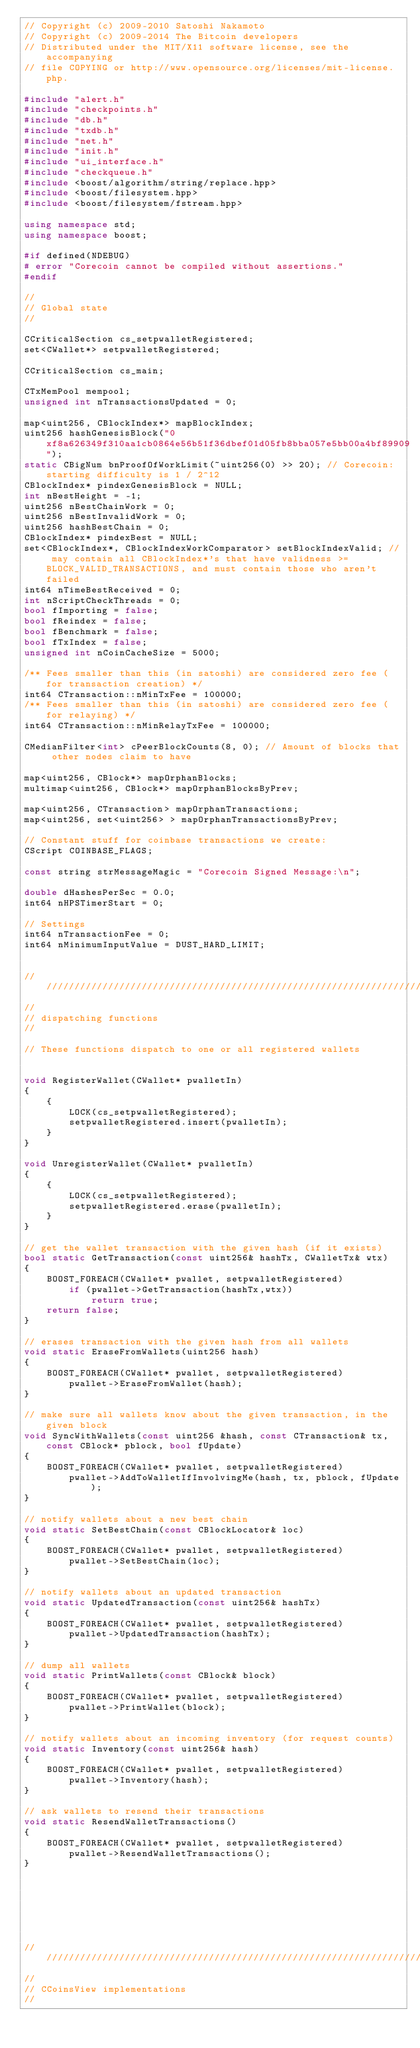Convert code to text. <code><loc_0><loc_0><loc_500><loc_500><_C++_>// Copyright (c) 2009-2010 Satoshi Nakamoto
// Copyright (c) 2009-2014 The Bitcoin developers
// Distributed under the MIT/X11 software license, see the accompanying
// file COPYING or http://www.opensource.org/licenses/mit-license.php.

#include "alert.h"
#include "checkpoints.h"
#include "db.h"
#include "txdb.h"
#include "net.h"
#include "init.h"
#include "ui_interface.h"
#include "checkqueue.h"
#include <boost/algorithm/string/replace.hpp>
#include <boost/filesystem.hpp>
#include <boost/filesystem/fstream.hpp>

using namespace std;
using namespace boost;

#if defined(NDEBUG)
# error "Corecoin cannot be compiled without assertions."
#endif

//
// Global state
//

CCriticalSection cs_setpwalletRegistered;
set<CWallet*> setpwalletRegistered;

CCriticalSection cs_main;

CTxMemPool mempool;
unsigned int nTransactionsUpdated = 0;

map<uint256, CBlockIndex*> mapBlockIndex;
uint256 hashGenesisBlock("0xf8a626349f310aa1cb0864e56b51f36dbef01d05fb8bba057e5bb00a4bf89909");
static CBigNum bnProofOfWorkLimit(~uint256(0) >> 20); // Corecoin: starting difficulty is 1 / 2^12
CBlockIndex* pindexGenesisBlock = NULL;
int nBestHeight = -1;
uint256 nBestChainWork = 0;
uint256 nBestInvalidWork = 0;
uint256 hashBestChain = 0;
CBlockIndex* pindexBest = NULL;
set<CBlockIndex*, CBlockIndexWorkComparator> setBlockIndexValid; // may contain all CBlockIndex*'s that have validness >=BLOCK_VALID_TRANSACTIONS, and must contain those who aren't failed
int64 nTimeBestReceived = 0;
int nScriptCheckThreads = 0;
bool fImporting = false;
bool fReindex = false;
bool fBenchmark = false;
bool fTxIndex = false;
unsigned int nCoinCacheSize = 5000;

/** Fees smaller than this (in satoshi) are considered zero fee (for transaction creation) */
int64 CTransaction::nMinTxFee = 100000;
/** Fees smaller than this (in satoshi) are considered zero fee (for relaying) */
int64 CTransaction::nMinRelayTxFee = 100000;

CMedianFilter<int> cPeerBlockCounts(8, 0); // Amount of blocks that other nodes claim to have

map<uint256, CBlock*> mapOrphanBlocks;
multimap<uint256, CBlock*> mapOrphanBlocksByPrev;

map<uint256, CTransaction> mapOrphanTransactions;
map<uint256, set<uint256> > mapOrphanTransactionsByPrev;

// Constant stuff for coinbase transactions we create:
CScript COINBASE_FLAGS;

const string strMessageMagic = "Corecoin Signed Message:\n";

double dHashesPerSec = 0.0;
int64 nHPSTimerStart = 0;

// Settings
int64 nTransactionFee = 0;
int64 nMinimumInputValue = DUST_HARD_LIMIT;


//////////////////////////////////////////////////////////////////////////////
//
// dispatching functions
//

// These functions dispatch to one or all registered wallets


void RegisterWallet(CWallet* pwalletIn)
{
    {
        LOCK(cs_setpwalletRegistered);
        setpwalletRegistered.insert(pwalletIn);
    }
}

void UnregisterWallet(CWallet* pwalletIn)
{
    {
        LOCK(cs_setpwalletRegistered);
        setpwalletRegistered.erase(pwalletIn);
    }
}

// get the wallet transaction with the given hash (if it exists)
bool static GetTransaction(const uint256& hashTx, CWalletTx& wtx)
{
    BOOST_FOREACH(CWallet* pwallet, setpwalletRegistered)
        if (pwallet->GetTransaction(hashTx,wtx))
            return true;
    return false;
}

// erases transaction with the given hash from all wallets
void static EraseFromWallets(uint256 hash)
{
    BOOST_FOREACH(CWallet* pwallet, setpwalletRegistered)
        pwallet->EraseFromWallet(hash);
}

// make sure all wallets know about the given transaction, in the given block
void SyncWithWallets(const uint256 &hash, const CTransaction& tx, const CBlock* pblock, bool fUpdate)
{
    BOOST_FOREACH(CWallet* pwallet, setpwalletRegistered)
        pwallet->AddToWalletIfInvolvingMe(hash, tx, pblock, fUpdate);
}

// notify wallets about a new best chain
void static SetBestChain(const CBlockLocator& loc)
{
    BOOST_FOREACH(CWallet* pwallet, setpwalletRegistered)
        pwallet->SetBestChain(loc);
}

// notify wallets about an updated transaction
void static UpdatedTransaction(const uint256& hashTx)
{
    BOOST_FOREACH(CWallet* pwallet, setpwalletRegistered)
        pwallet->UpdatedTransaction(hashTx);
}

// dump all wallets
void static PrintWallets(const CBlock& block)
{
    BOOST_FOREACH(CWallet* pwallet, setpwalletRegistered)
        pwallet->PrintWallet(block);
}

// notify wallets about an incoming inventory (for request counts)
void static Inventory(const uint256& hash)
{
    BOOST_FOREACH(CWallet* pwallet, setpwalletRegistered)
        pwallet->Inventory(hash);
}

// ask wallets to resend their transactions
void static ResendWalletTransactions()
{
    BOOST_FOREACH(CWallet* pwallet, setpwalletRegistered)
        pwallet->ResendWalletTransactions();
}







//////////////////////////////////////////////////////////////////////////////
//
// CCoinsView implementations
//
</code> 